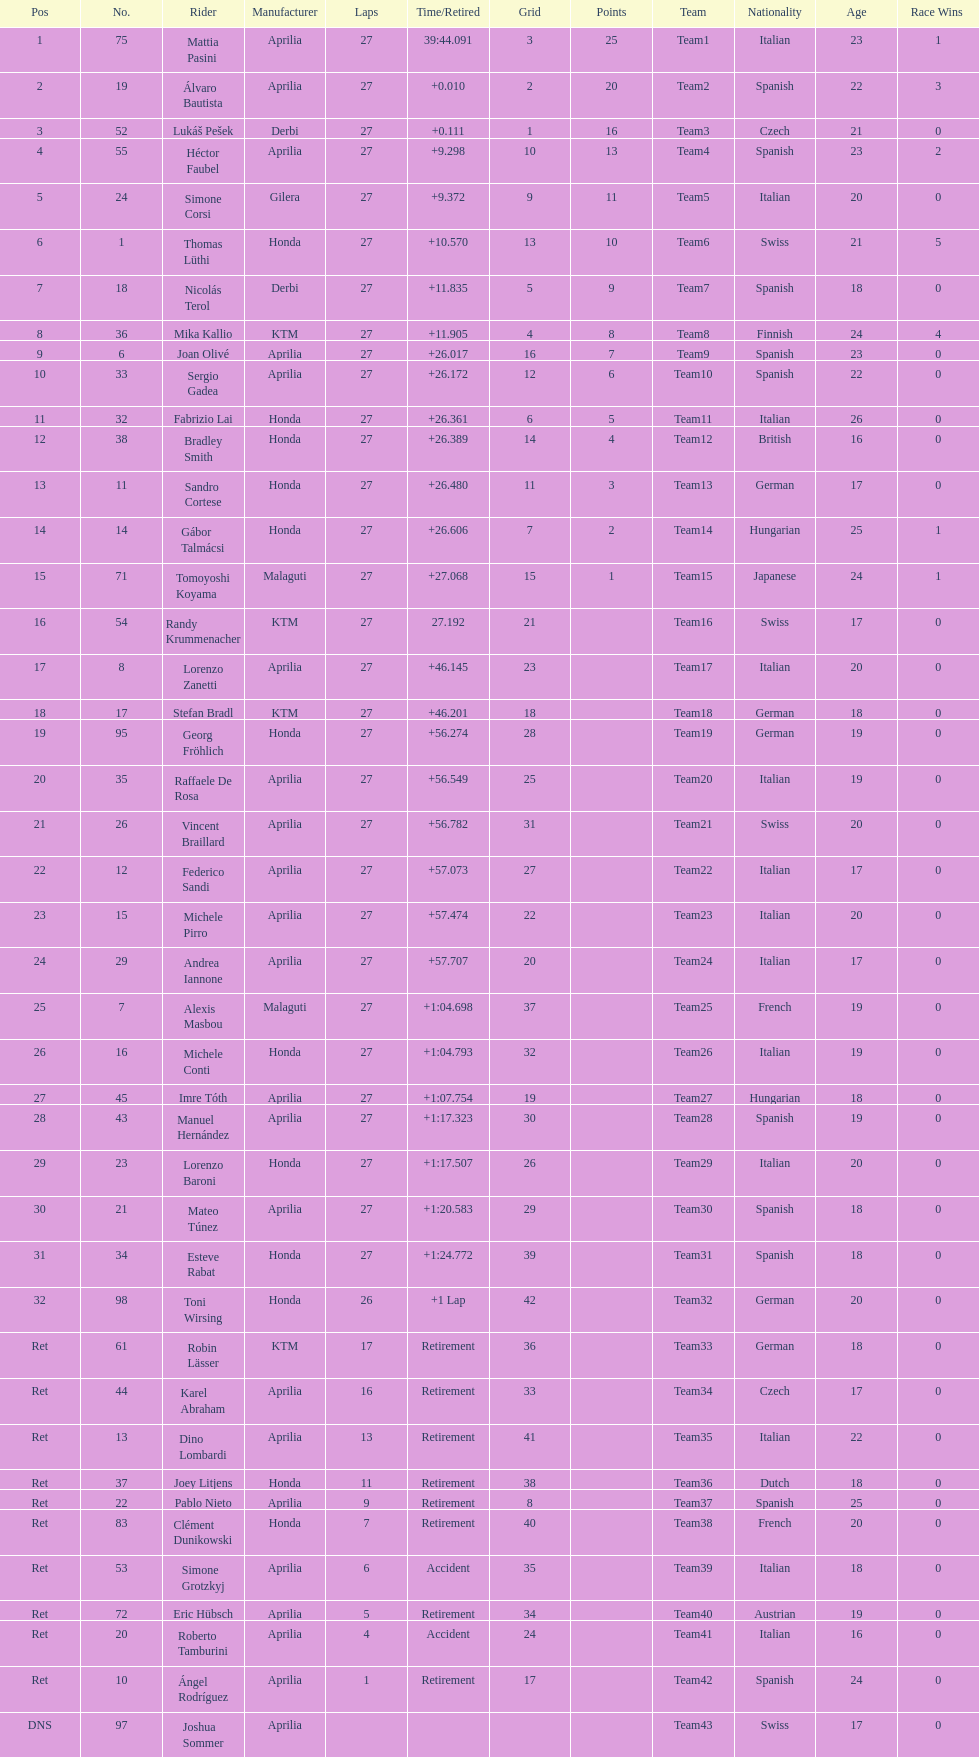Out of all the people who have points, who has the least? Tomoyoshi Koyama. Parse the full table. {'header': ['Pos', 'No.', 'Rider', 'Manufacturer', 'Laps', 'Time/Retired', 'Grid', 'Points', 'Team', 'Nationality', 'Age', 'Race Wins\r'], 'rows': [['1', '75', 'Mattia Pasini', 'Aprilia', '27', '39:44.091', '3', '25', 'Team1', 'Italian', '23', '1\r'], ['2', '19', 'Álvaro Bautista', 'Aprilia', '27', '+0.010', '2', '20', 'Team2', 'Spanish', '22', '3\r'], ['3', '52', 'Lukáš Pešek', 'Derbi', '27', '+0.111', '1', '16', 'Team3', 'Czech', '21', '0\r'], ['4', '55', 'Héctor Faubel', 'Aprilia', '27', '+9.298', '10', '13', 'Team4', 'Spanish', '23', '2\r'], ['5', '24', 'Simone Corsi', 'Gilera', '27', '+9.372', '9', '11', 'Team5', 'Italian', '20', '0\r'], ['6', '1', 'Thomas Lüthi', 'Honda', '27', '+10.570', '13', '10', 'Team6', 'Swiss', '21', '5\r'], ['7', '18', 'Nicolás Terol', 'Derbi', '27', '+11.835', '5', '9', 'Team7', 'Spanish', '18', '0\r'], ['8', '36', 'Mika Kallio', 'KTM', '27', '+11.905', '4', '8', 'Team8', 'Finnish', '24', '4\r'], ['9', '6', 'Joan Olivé', 'Aprilia', '27', '+26.017', '16', '7', 'Team9', 'Spanish', '23', '0\r'], ['10', '33', 'Sergio Gadea', 'Aprilia', '27', '+26.172', '12', '6', 'Team10', 'Spanish', '22', '0\r'], ['11', '32', 'Fabrizio Lai', 'Honda', '27', '+26.361', '6', '5', 'Team11', 'Italian', '26', '0\r'], ['12', '38', 'Bradley Smith', 'Honda', '27', '+26.389', '14', '4', 'Team12', 'British', '16', '0\r'], ['13', '11', 'Sandro Cortese', 'Honda', '27', '+26.480', '11', '3', 'Team13', 'German', '17', '0\r'], ['14', '14', 'Gábor Talmácsi', 'Honda', '27', '+26.606', '7', '2', 'Team14', 'Hungarian', '25', '1\r'], ['15', '71', 'Tomoyoshi Koyama', 'Malaguti', '27', '+27.068', '15', '1', 'Team15', 'Japanese', '24', '1\r'], ['16', '54', 'Randy Krummenacher', 'KTM', '27', '27.192', '21', '', 'Team16', 'Swiss', '17', '0\r'], ['17', '8', 'Lorenzo Zanetti', 'Aprilia', '27', '+46.145', '23', '', 'Team17', 'Italian', '20', '0\r'], ['18', '17', 'Stefan Bradl', 'KTM', '27', '+46.201', '18', '', 'Team18', 'German', '18', '0\r'], ['19', '95', 'Georg Fröhlich', 'Honda', '27', '+56.274', '28', '', 'Team19', 'German', '19', '0\r'], ['20', '35', 'Raffaele De Rosa', 'Aprilia', '27', '+56.549', '25', '', 'Team20', 'Italian', '19', '0\r'], ['21', '26', 'Vincent Braillard', 'Aprilia', '27', '+56.782', '31', '', 'Team21', 'Swiss', '20', '0\r'], ['22', '12', 'Federico Sandi', 'Aprilia', '27', '+57.073', '27', '', 'Team22', 'Italian', '17', '0\r'], ['23', '15', 'Michele Pirro', 'Aprilia', '27', '+57.474', '22', '', 'Team23', 'Italian', '20', '0\r'], ['24', '29', 'Andrea Iannone', 'Aprilia', '27', '+57.707', '20', '', 'Team24', 'Italian', '17', '0\r'], ['25', '7', 'Alexis Masbou', 'Malaguti', '27', '+1:04.698', '37', '', 'Team25', 'French', '19', '0\r'], ['26', '16', 'Michele Conti', 'Honda', '27', '+1:04.793', '32', '', 'Team26', 'Italian', '19', '0\r'], ['27', '45', 'Imre Tóth', 'Aprilia', '27', '+1:07.754', '19', '', 'Team27', 'Hungarian', '18', '0\r'], ['28', '43', 'Manuel Hernández', 'Aprilia', '27', '+1:17.323', '30', '', 'Team28', 'Spanish', '19', '0\r'], ['29', '23', 'Lorenzo Baroni', 'Honda', '27', '+1:17.507', '26', '', 'Team29', 'Italian', '20', '0\r'], ['30', '21', 'Mateo Túnez', 'Aprilia', '27', '+1:20.583', '29', '', 'Team30', 'Spanish', '18', '0\r'], ['31', '34', 'Esteve Rabat', 'Honda', '27', '+1:24.772', '39', '', 'Team31', 'Spanish', '18', '0\r'], ['32', '98', 'Toni Wirsing', 'Honda', '26', '+1 Lap', '42', '', 'Team32', 'German', '20', '0\r'], ['Ret', '61', 'Robin Lässer', 'KTM', '17', 'Retirement', '36', '', 'Team33', 'German', '18', '0\r'], ['Ret', '44', 'Karel Abraham', 'Aprilia', '16', 'Retirement', '33', '', 'Team34', 'Czech', '17', '0\r'], ['Ret', '13', 'Dino Lombardi', 'Aprilia', '13', 'Retirement', '41', '', 'Team35', 'Italian', '22', '0\r'], ['Ret', '37', 'Joey Litjens', 'Honda', '11', 'Retirement', '38', '', 'Team36', 'Dutch', '18', '0\r'], ['Ret', '22', 'Pablo Nieto', 'Aprilia', '9', 'Retirement', '8', '', 'Team37', 'Spanish', '25', '0\r'], ['Ret', '83', 'Clément Dunikowski', 'Honda', '7', 'Retirement', '40', '', 'Team38', 'French', '20', '0\r'], ['Ret', '53', 'Simone Grotzkyj', 'Aprilia', '6', 'Accident', '35', '', 'Team39', 'Italian', '18', '0\r'], ['Ret', '72', 'Eric Hübsch', 'Aprilia', '5', 'Retirement', '34', '', 'Team40', 'Austrian', '19', '0\r'], ['Ret', '20', 'Roberto Tamburini', 'Aprilia', '4', 'Accident', '24', '', 'Team41', 'Italian', '16', '0\r'], ['Ret', '10', 'Ángel Rodríguez', 'Aprilia', '1', 'Retirement', '17', '', 'Team42', 'Spanish', '24', '0\r'], ['DNS', '97', 'Joshua Sommer', 'Aprilia', '', '', '', '', 'Team43', 'Swiss', '17', '0']]} 